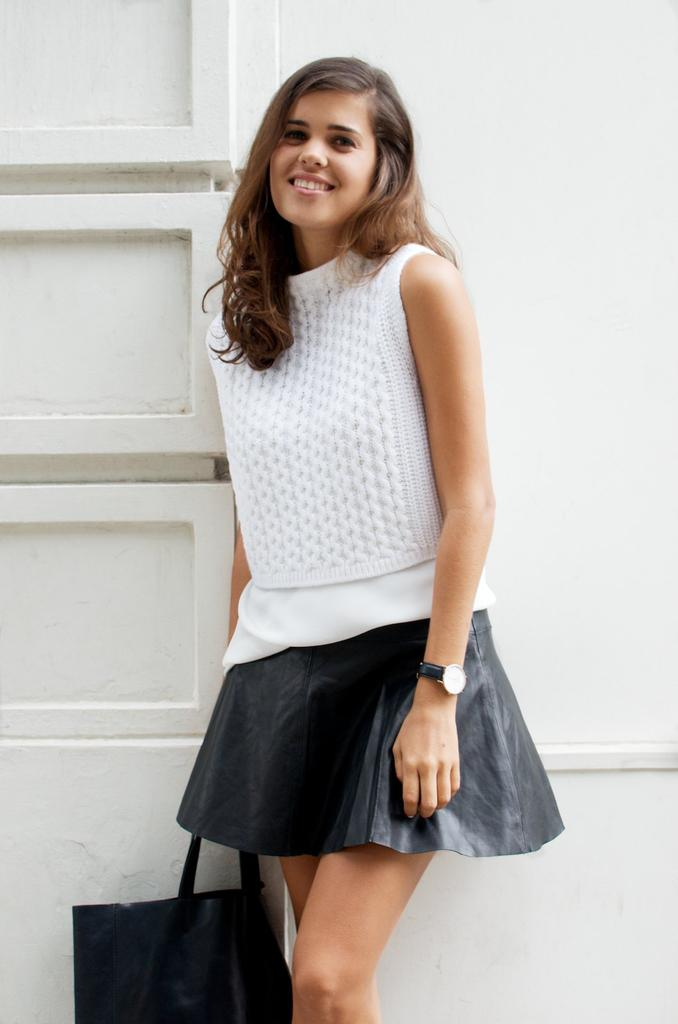Who is present in the image? There is a woman in the picture. What expression does the woman have? The woman is smiling. What is the woman holding in her hand? The woman is holding a bag in her hand. What substance is the woman using to enhance her brain in the image? There is no indication in the image that the woman is using any substance to enhance her brain. 